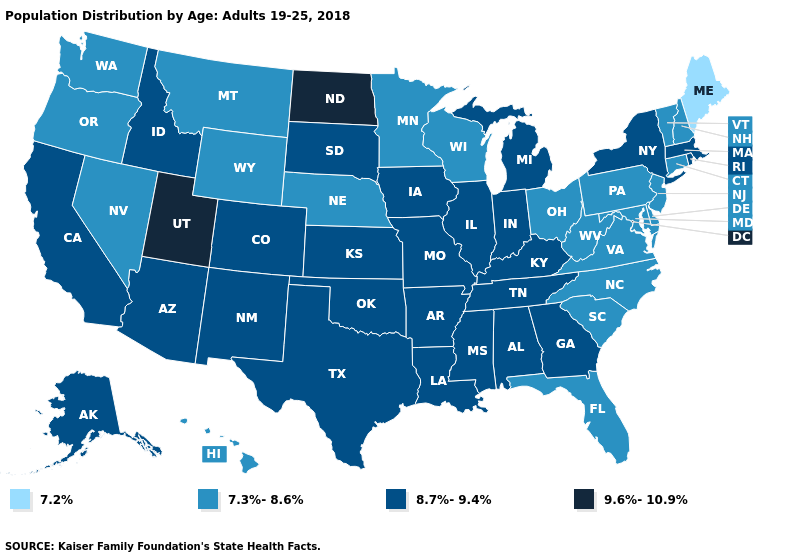What is the lowest value in the South?
Be succinct. 7.3%-8.6%. Name the states that have a value in the range 9.6%-10.9%?
Answer briefly. North Dakota, Utah. Among the states that border Missouri , does Kansas have the lowest value?
Answer briefly. No. Is the legend a continuous bar?
Give a very brief answer. No. Does Tennessee have the lowest value in the USA?
Answer briefly. No. Does the map have missing data?
Short answer required. No. Does Maine have the lowest value in the Northeast?
Be succinct. Yes. Name the states that have a value in the range 7.2%?
Quick response, please. Maine. What is the value of California?
Quick response, please. 8.7%-9.4%. Name the states that have a value in the range 7.2%?
Be succinct. Maine. Is the legend a continuous bar?
Answer briefly. No. Does North Dakota have the highest value in the USA?
Quick response, please. Yes. How many symbols are there in the legend?
Short answer required. 4. Which states have the lowest value in the MidWest?
Be succinct. Minnesota, Nebraska, Ohio, Wisconsin. 